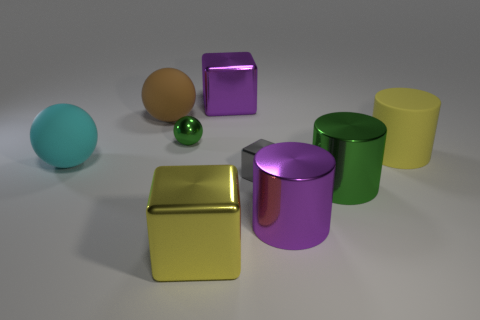Subtract all shiny cylinders. How many cylinders are left? 1 Add 1 big purple cylinders. How many objects exist? 10 Subtract all gray blocks. How many blocks are left? 2 Subtract all balls. How many objects are left? 6 Subtract 3 balls. How many balls are left? 0 Subtract all yellow cylinders. Subtract all gray blocks. How many cylinders are left? 2 Subtract all blue balls. How many yellow cylinders are left? 1 Subtract all large purple metal cylinders. Subtract all large matte cylinders. How many objects are left? 7 Add 6 brown balls. How many brown balls are left? 7 Add 4 big rubber spheres. How many big rubber spheres exist? 6 